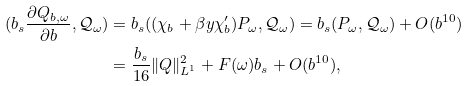<formula> <loc_0><loc_0><loc_500><loc_500>( b _ { s } \frac { \partial Q _ { b , \omega } } { \partial b } , \mathcal { Q } _ { \omega } ) & = b _ { s } ( ( \chi _ { b } + \beta y \chi _ { b } ^ { \prime } ) P _ { \omega } , \mathcal { Q } _ { \omega } ) = b _ { s } ( P _ { \omega } , \mathcal { Q } _ { \omega } ) + O ( b ^ { 1 0 } ) \\ & = \frac { b _ { s } } { 1 6 } \| Q \| _ { L ^ { 1 } } ^ { 2 } + F ( \omega ) b _ { s } + O ( b ^ { 1 0 } ) ,</formula> 